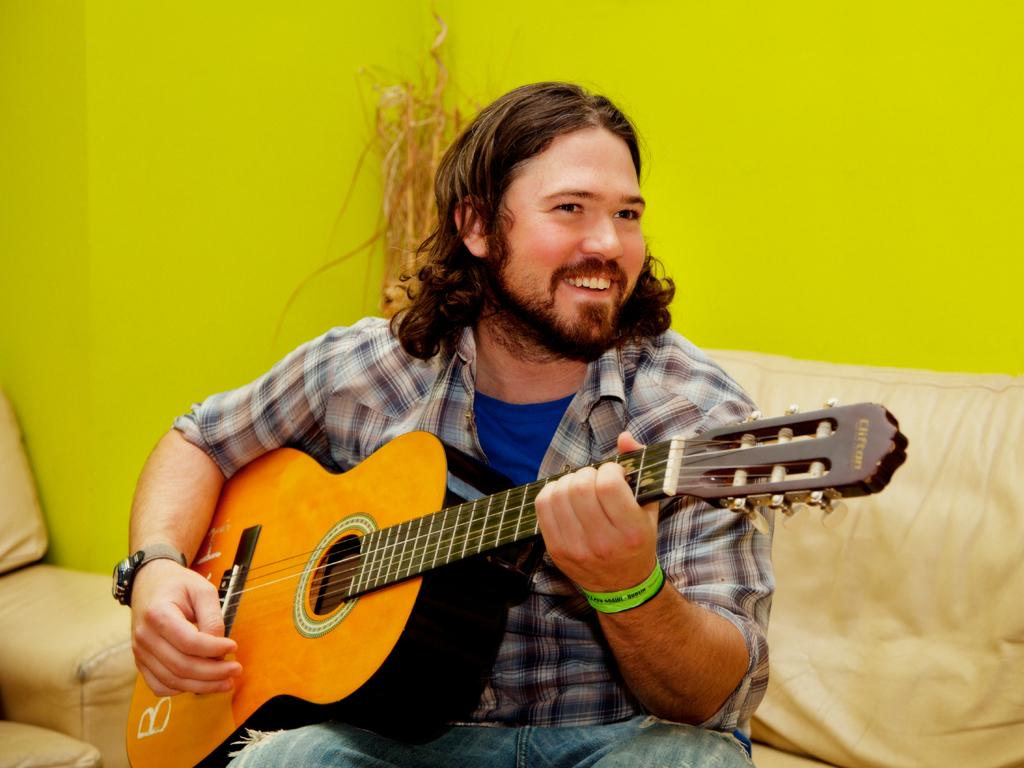What is the main subject of the image? The main subject of the image is a man. What is the man doing in the image? The man is playing a guitar in the image. Where is the man seated in the image? The man is seated on a sofa in the image. What type of scene is the man reading in the image? There is no scene or reading material present in the image; the man is playing a guitar. What degree of difficulty is the man playing the guitar at in the image? There is no indication of the difficulty level of the guitar playing in the image. 